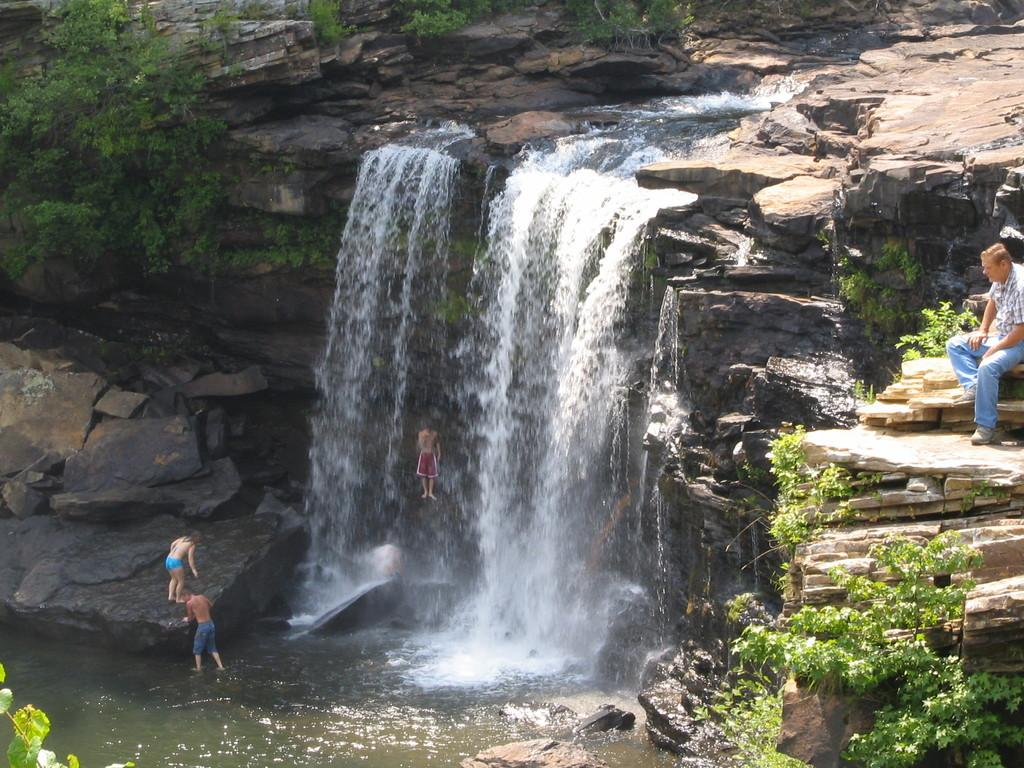How many people are present in the image? There are four people in the image. What else can be seen in the image besides the people? There are plants, water, and rocks visible in the image. Can you describe the position of one of the people in the image? There is a man sitting in the image. What type of credit card is the man using to push the rocks in the image? There is no credit card or pushing of rocks present in the image. 